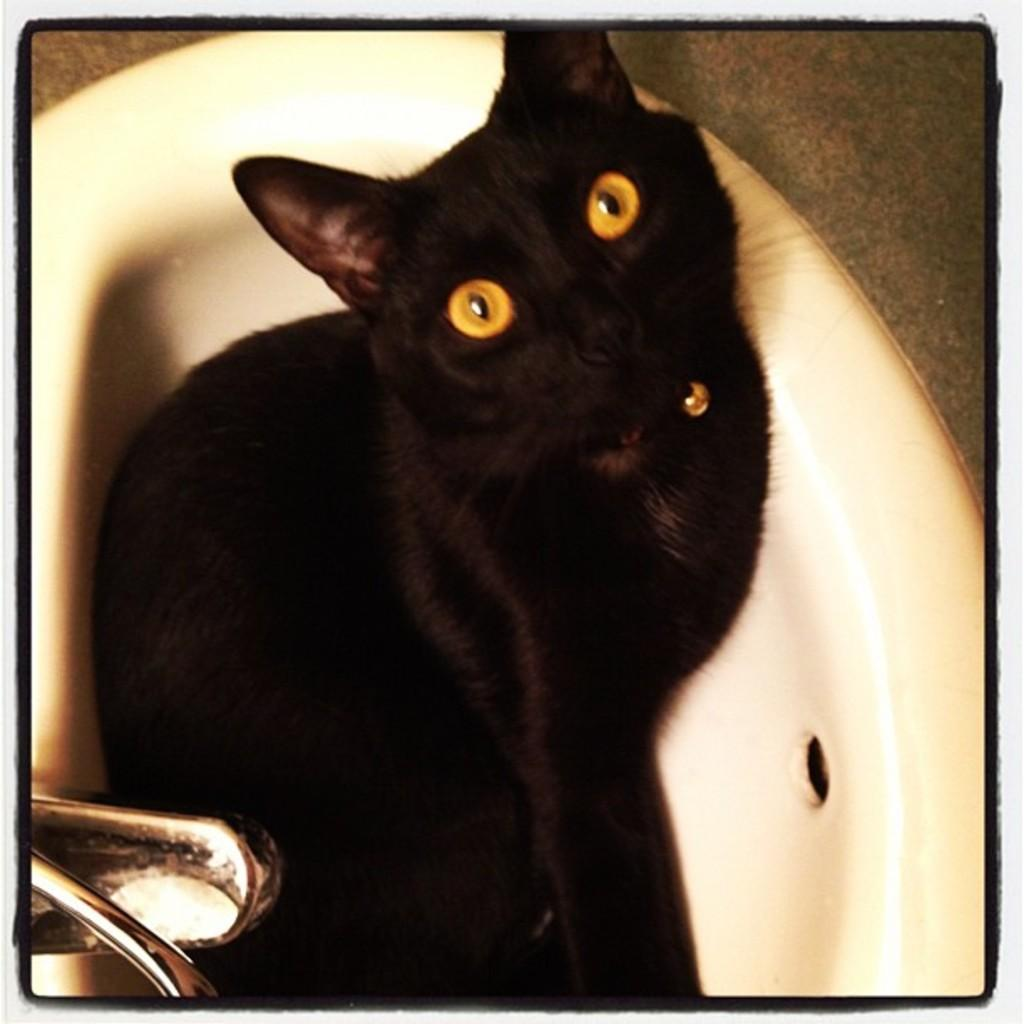What type of animal is in the image? There is a black cat in the image. Where is the cat located? The cat is in a white sink. Can you describe any other objects in the image? There is a silver tap in the left side bottom corner of the image. What can be seen at the top of the image? The top of the image shows a surface. What type of lumber is being used by the laborer in the image? There is no laborer or lumber present in the image; it features a black cat in a white sink with a silver tap. What act is the cat performing in the image? The image does not depict the cat performing any specific act; it is simply sitting in the sink. 